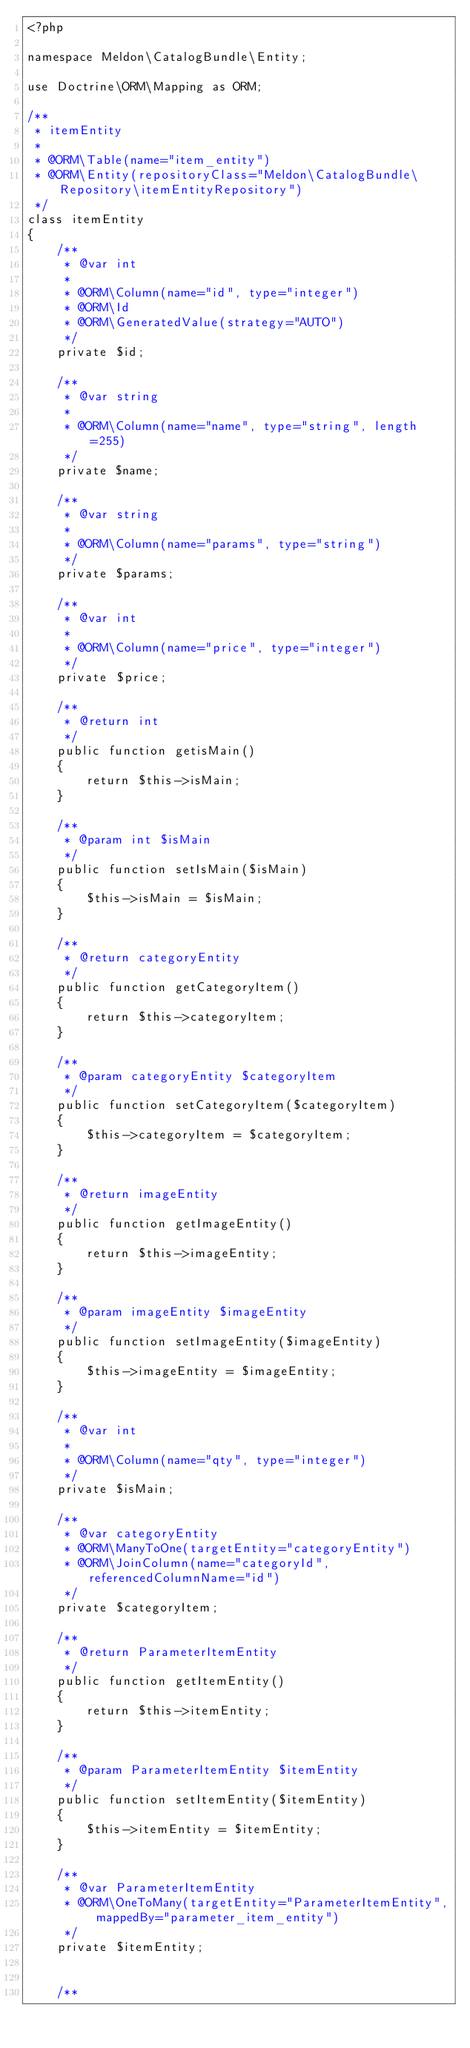<code> <loc_0><loc_0><loc_500><loc_500><_PHP_><?php

namespace Meldon\CatalogBundle\Entity;

use Doctrine\ORM\Mapping as ORM;

/**
 * itemEntity
 *
 * @ORM\Table(name="item_entity")
 * @ORM\Entity(repositoryClass="Meldon\CatalogBundle\Repository\itemEntityRepository")
 */
class itemEntity
{
    /**
     * @var int
     *
     * @ORM\Column(name="id", type="integer")
     * @ORM\Id
     * @ORM\GeneratedValue(strategy="AUTO")
     */
    private $id;

    /**
     * @var string
     *
     * @ORM\Column(name="name", type="string", length=255)
     */
    private $name;

    /**
     * @var string
     *
     * @ORM\Column(name="params", type="string")
     */
    private $params;

    /**
     * @var int
     *
     * @ORM\Column(name="price", type="integer")
     */
    private $price;

    /**
     * @return int
     */
    public function getisMain()
    {
        return $this->isMain;
    }

    /**
     * @param int $isMain
     */
    public function setIsMain($isMain)
    {
        $this->isMain = $isMain;
    }

    /**
     * @return categoryEntity
     */
    public function getCategoryItem()
    {
        return $this->categoryItem;
    }

    /**
     * @param categoryEntity $categoryItem
     */
    public function setCategoryItem($categoryItem)
    {
        $this->categoryItem = $categoryItem;
    }

    /**
     * @return imageEntity
     */
    public function getImageEntity()
    {
        return $this->imageEntity;
    }

    /**
     * @param imageEntity $imageEntity
     */
    public function setImageEntity($imageEntity)
    {
        $this->imageEntity = $imageEntity;
    }

    /**
     * @var int
     *
     * @ORM\Column(name="qty", type="integer")
     */
    private $isMain;

    /**
     * @var categoryEntity
     * @ORM\ManyToOne(targetEntity="categoryEntity")
     * @ORM\JoinColumn(name="categoryId", referencedColumnName="id")
     */
    private $categoryItem;

    /**
     * @return ParameterItemEntity
     */
    public function getItemEntity()
    {
        return $this->itemEntity;
    }

    /**
     * @param ParameterItemEntity $itemEntity
     */
    public function setItemEntity($itemEntity)
    {
        $this->itemEntity = $itemEntity;
    }

    /**
     * @var ParameterItemEntity
     * @ORM\OneToMany(targetEntity="ParameterItemEntity", mappedBy="parameter_item_entity")
     */
    private $itemEntity;


    /**</code> 